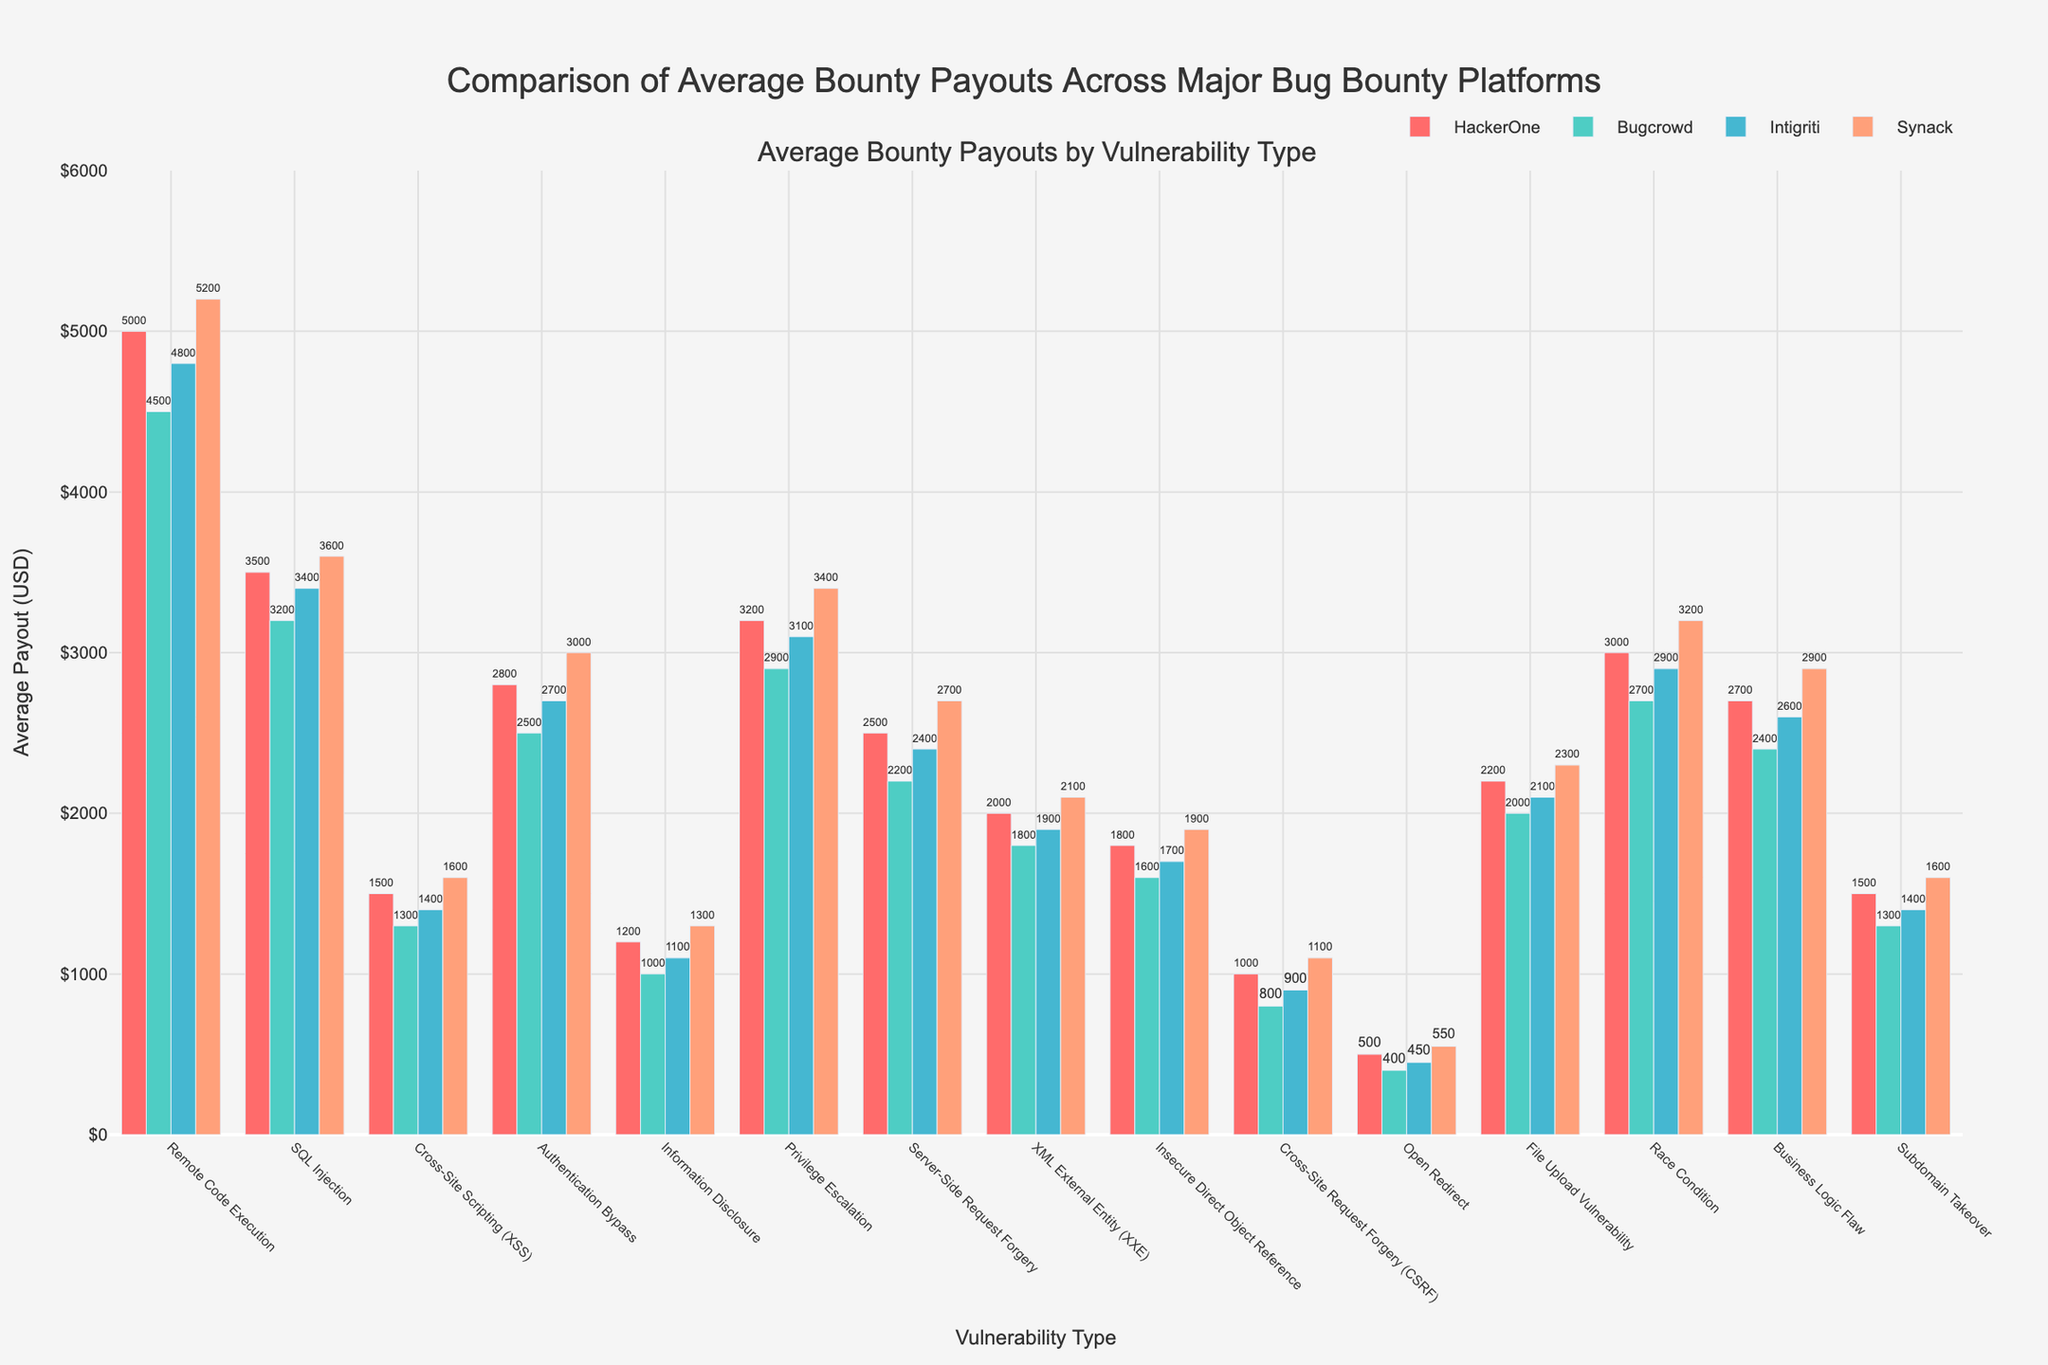Which platform offers the highest average bounty payout for Remote Code Execution vulnerabilities? According to the figure, for Remote Code Execution vulnerabilities, Synack offers the highest average bounty payout compared to other platforms. This can be identified by the tallest bar representing Synack in the provided vulnerability type.
Answer: Synack Which vulnerability type has the lowest average bounty payout across all platforms? The figure shows that across all platforms, Open Redirect has the lowest average payouts, indicated by the shortest bars in the chart.
Answer: Open Redirect Between HackerOne and Bugcrowd, which platform offers higher payouts for SQL Injection vulnerabilities, and by how much? The figure illustrates that HackerOne offers $3500 for SQL Injection vulnerabilities, whereas Bugcrowd offers $3200. The difference is $3500 - $3200 = $300.
Answer: HackerOne, $300 What is the average payout for Information Disclosure vulnerabilities across all platforms? To find the average payout, sum the payouts for Information Disclosure across all platforms and then divide by the number of platforms. The payouts are $1200, $1000, $1100, $1300. Sum these: $1200 + $1000 + $1100 + $1300 = $4600. Then, divide by 4: $4600 / 4 = $1150.
Answer: $1150 How much higher is the payout for Privilege Escalation vulnerabilities on Synack compared to Intigriti? Synack offers $3400 and Intigriti offers $3100 for Privilege Escalation. The difference is $3400 - $3100 = $300.
Answer: $300 Which platform provides approximately equal payouts for Business Logic Flaw and Authentication Bypass vulnerabilities? The figure shows that Bugcrowd provides approximately equal payouts for Business Logic Flaw ($2400) and Authentication Bypass ($2500), as the heights of the respective bars are nearly the same.
Answer: Bugcrowd What is the total average payout for Cross-Site Scripting vulnerabilities across all platforms combined? Sum the payouts for Cross-Site Scripting for all platforms: $1500 (HackerOne) + $1300 (Bugcrowd) + $1400 (Intigriti) + $1600 (Synack). Total is $1500 + $1300 + $1400 + $1600 = $5800.
Answer: $5800 If we consider only HackerOne and Synack, for which vulnerability type is the payout difference between these two platforms the smallest? The smallest difference is observed in "Subdomain Takeover" where HackerOne offers $1500 and Synack offers $1600. The difference is $1600 - $1500 = $100.
Answer: Subdomain Takeover 